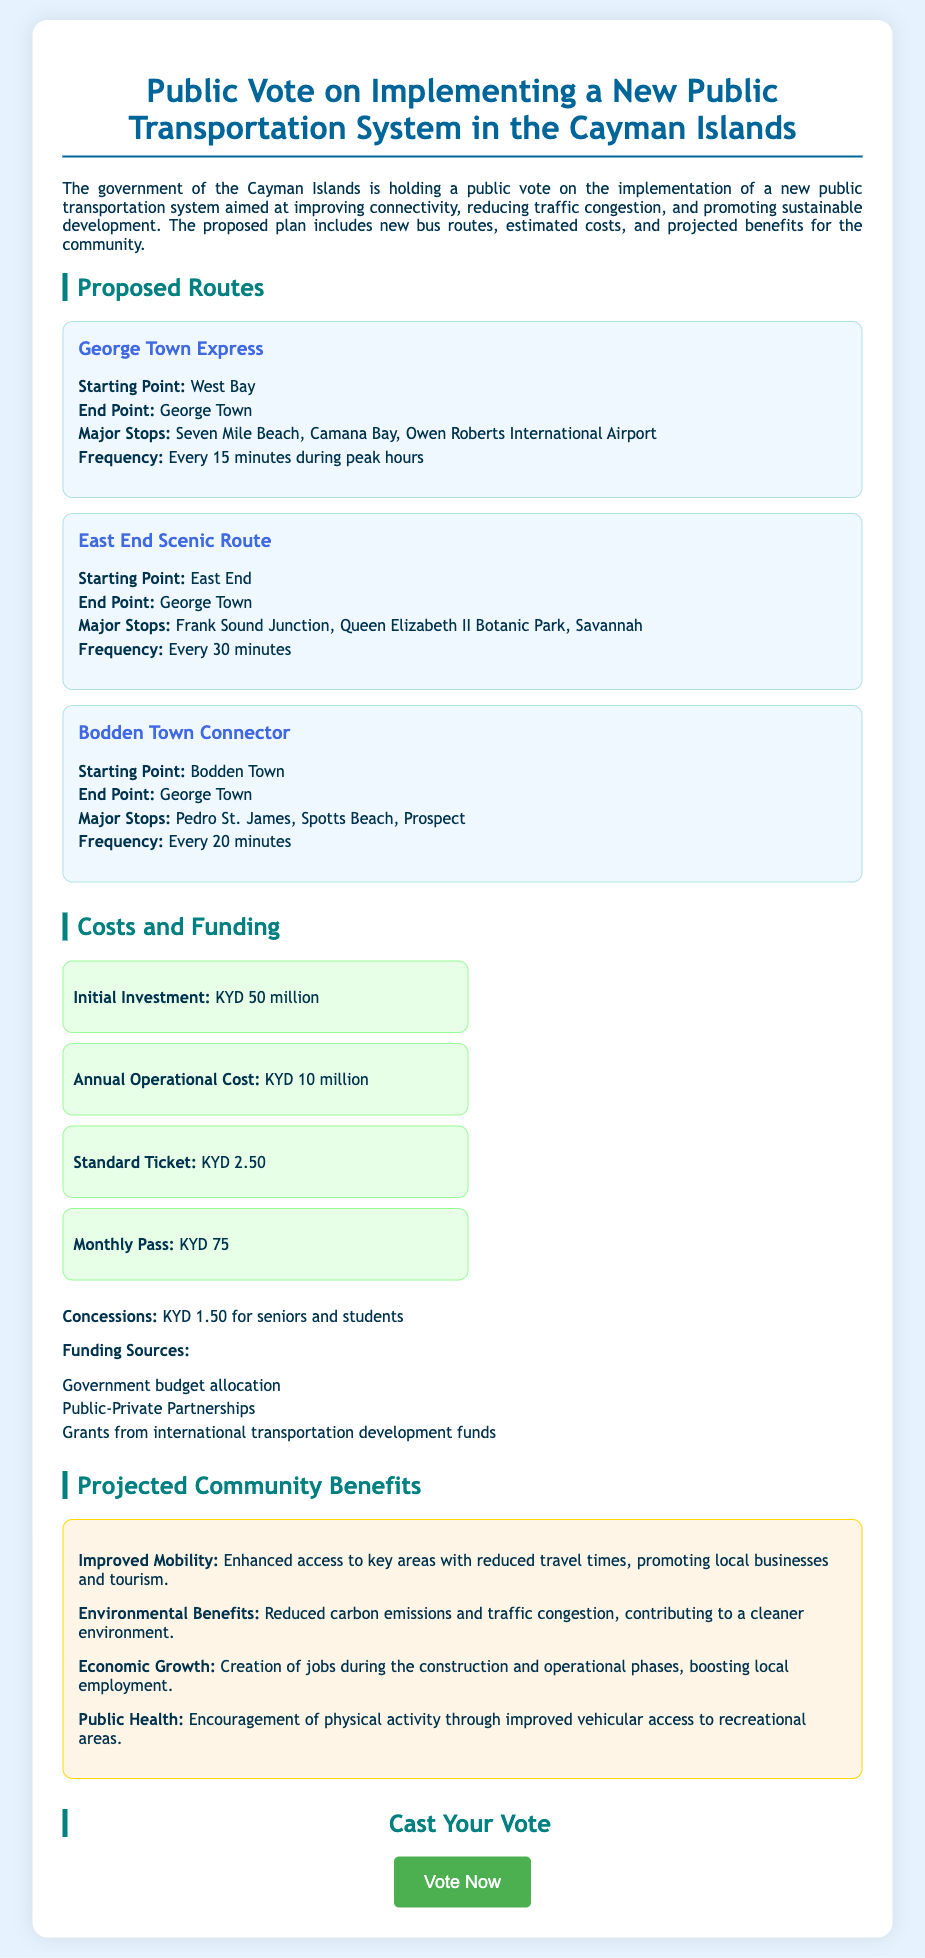What is the starting point of the George Town Express? The starting point of the George Town Express route is listed in the proposed routes section of the document.
Answer: West Bay What is the frequency of the Bodden Town Connector? The frequency of the Bodden Town Connector is mentioned in the route details, which indicates how often the service operates.
Answer: Every 20 minutes What is the initial investment required for the public transportation system? The initial investment needed is specified under the costs and funding section of the document.
Answer: KYD 50 million What is the concession price for seniors and students? The document provides specific pricing details, including concessions available for certain groups.
Answer: KYD 1.50 Name one major stop on the East End Scenic Route. The major stops are listed in the route description, and the question asks for any one of those stops.
Answer: Queen Elizabeth II Botanic Park How many proposed routes are outlined in the document? The total number of proposed routes can be counted from the section that details each route.
Answer: Three What are two of the projected community benefits mentioned? The benefits section outlines multiple benefits, and this question requires two of them.
Answer: Improved Mobility, Economic Growth What type of ticket is priced at KYD 2.50? The ticket pricing section details the various ticket types and their costs, including this specific ticket.
Answer: Standard Ticket Where will the George Town Express end? The end point of the George Town Express is listed in the route description under the proposed routes section.
Answer: George Town 